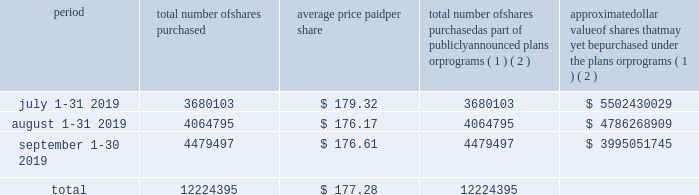Part ii item 5 .
Market for registrant 2019s common equity , related stockholder matters and issuer purchases of equity securities our class a common stock has been listed on the new york stock exchange under the symbol 201cv 201d since march 19 , 2008 .
At november 8 , 2019 , we had 348 stockholders of record of our class a common stock .
The number of beneficial owners is substantially greater than the number of record holders , because a large portion of our class a common stock is held in 201cstreet name 201d by banks and brokers .
There is currently no established public trading market for our class b or c common stock .
There were 1397 and 509 holders of record of our class b and c common stock , respectively , as of november 8 , 2019 .
On october 22 , 2019 , our board of directors declared a quarterly cash dividend of $ 0.30 per share of class a common stock ( determined in the case of class b and c common stock and series b and c preferred stock on an as-converted basis ) payable on december 3 , 2019 , to holders of record as of november 15 , 2019 of our common and preferred stock .
Subject to legally available funds , we expect to continue paying quarterly cash dividends on our outstanding common and preferred stock in the future .
However , the declaration and payment of future dividends is at the sole discretion of our board of directors after taking into account various factors , including our financial condition , settlement indemnifications , operating results , available cash and current and anticipated cash needs .
Issuer purchases of equity securities the table below sets forth our purchases of common stock during the quarter ended september 30 , 2019 .
Period total number of shares purchased average price paid per share total number of shares purchased as part of publicly announced plans or programs ( 1 ) ( 2 ) approximate dollar value of shares that may yet be purchased under the plans or programs ( 1 ) ( 2 ) .
( 1 ) the figures in the table reflect transactions according to the trade dates .
For purposes of our consolidated financial statements included in this form 10-k , the impact of these repurchases is recorded according to the settlement dates .
( 2 ) our board of directors from time to time authorizes the repurchase of shares of our common stock up to a certain monetary limit .
In january 2019 , our board of directors authorized a share repurchase program for $ 8.5 billion .
This authorization has no expiration date .
All share repurchase programs authorized prior to january 2019 have been completed. .
What is the total cash spent for the repurchase of shares during the month of july 2019? 
Computations: (3680103 * 179.32)
Answer: 659916069.96. 